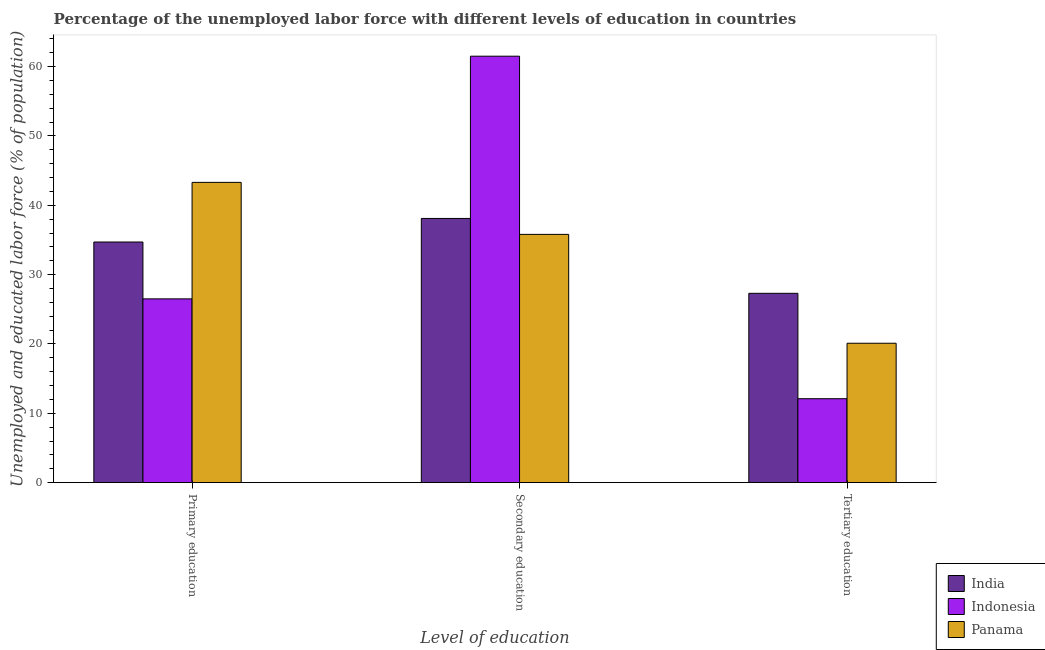How many different coloured bars are there?
Make the answer very short. 3. How many groups of bars are there?
Offer a terse response. 3. What is the label of the 3rd group of bars from the left?
Make the answer very short. Tertiary education. What is the percentage of labor force who received secondary education in Panama?
Provide a succinct answer. 35.8. Across all countries, what is the maximum percentage of labor force who received secondary education?
Provide a short and direct response. 61.5. Across all countries, what is the minimum percentage of labor force who received primary education?
Make the answer very short. 26.5. In which country was the percentage of labor force who received primary education maximum?
Provide a short and direct response. Panama. In which country was the percentage of labor force who received secondary education minimum?
Ensure brevity in your answer.  Panama. What is the total percentage of labor force who received tertiary education in the graph?
Ensure brevity in your answer.  59.5. What is the difference between the percentage of labor force who received tertiary education in Panama and that in India?
Give a very brief answer. -7.2. What is the difference between the percentage of labor force who received primary education in India and the percentage of labor force who received tertiary education in Indonesia?
Provide a succinct answer. 22.6. What is the average percentage of labor force who received tertiary education per country?
Give a very brief answer. 19.83. What is the difference between the percentage of labor force who received primary education and percentage of labor force who received secondary education in Indonesia?
Provide a short and direct response. -35. In how many countries, is the percentage of labor force who received primary education greater than 56 %?
Provide a succinct answer. 0. What is the ratio of the percentage of labor force who received tertiary education in Panama to that in Indonesia?
Ensure brevity in your answer.  1.66. Is the difference between the percentage of labor force who received secondary education in India and Panama greater than the difference between the percentage of labor force who received primary education in India and Panama?
Give a very brief answer. Yes. What is the difference between the highest and the second highest percentage of labor force who received secondary education?
Keep it short and to the point. 23.4. What is the difference between the highest and the lowest percentage of labor force who received secondary education?
Provide a succinct answer. 25.7. In how many countries, is the percentage of labor force who received tertiary education greater than the average percentage of labor force who received tertiary education taken over all countries?
Make the answer very short. 2. Is the sum of the percentage of labor force who received primary education in Panama and Indonesia greater than the maximum percentage of labor force who received tertiary education across all countries?
Provide a succinct answer. Yes. What does the 3rd bar from the left in Tertiary education represents?
Your response must be concise. Panama. What does the 3rd bar from the right in Primary education represents?
Give a very brief answer. India. Is it the case that in every country, the sum of the percentage of labor force who received primary education and percentage of labor force who received secondary education is greater than the percentage of labor force who received tertiary education?
Keep it short and to the point. Yes. How many bars are there?
Your response must be concise. 9. Are all the bars in the graph horizontal?
Offer a terse response. No. How many countries are there in the graph?
Give a very brief answer. 3. What is the difference between two consecutive major ticks on the Y-axis?
Provide a succinct answer. 10. Does the graph contain grids?
Ensure brevity in your answer.  No. How are the legend labels stacked?
Offer a terse response. Vertical. What is the title of the graph?
Make the answer very short. Percentage of the unemployed labor force with different levels of education in countries. Does "Moldova" appear as one of the legend labels in the graph?
Provide a short and direct response. No. What is the label or title of the X-axis?
Provide a succinct answer. Level of education. What is the label or title of the Y-axis?
Your answer should be compact. Unemployed and educated labor force (% of population). What is the Unemployed and educated labor force (% of population) of India in Primary education?
Offer a terse response. 34.7. What is the Unemployed and educated labor force (% of population) in Panama in Primary education?
Your answer should be very brief. 43.3. What is the Unemployed and educated labor force (% of population) of India in Secondary education?
Give a very brief answer. 38.1. What is the Unemployed and educated labor force (% of population) of Indonesia in Secondary education?
Your answer should be compact. 61.5. What is the Unemployed and educated labor force (% of population) of Panama in Secondary education?
Provide a succinct answer. 35.8. What is the Unemployed and educated labor force (% of population) in India in Tertiary education?
Make the answer very short. 27.3. What is the Unemployed and educated labor force (% of population) of Indonesia in Tertiary education?
Provide a short and direct response. 12.1. What is the Unemployed and educated labor force (% of population) in Panama in Tertiary education?
Your response must be concise. 20.1. Across all Level of education, what is the maximum Unemployed and educated labor force (% of population) in India?
Offer a terse response. 38.1. Across all Level of education, what is the maximum Unemployed and educated labor force (% of population) in Indonesia?
Offer a very short reply. 61.5. Across all Level of education, what is the maximum Unemployed and educated labor force (% of population) of Panama?
Give a very brief answer. 43.3. Across all Level of education, what is the minimum Unemployed and educated labor force (% of population) of India?
Provide a short and direct response. 27.3. Across all Level of education, what is the minimum Unemployed and educated labor force (% of population) in Indonesia?
Give a very brief answer. 12.1. Across all Level of education, what is the minimum Unemployed and educated labor force (% of population) in Panama?
Ensure brevity in your answer.  20.1. What is the total Unemployed and educated labor force (% of population) in India in the graph?
Provide a succinct answer. 100.1. What is the total Unemployed and educated labor force (% of population) in Indonesia in the graph?
Offer a terse response. 100.1. What is the total Unemployed and educated labor force (% of population) in Panama in the graph?
Provide a short and direct response. 99.2. What is the difference between the Unemployed and educated labor force (% of population) in India in Primary education and that in Secondary education?
Offer a very short reply. -3.4. What is the difference between the Unemployed and educated labor force (% of population) in Indonesia in Primary education and that in Secondary education?
Your answer should be very brief. -35. What is the difference between the Unemployed and educated labor force (% of population) of India in Primary education and that in Tertiary education?
Offer a terse response. 7.4. What is the difference between the Unemployed and educated labor force (% of population) in Panama in Primary education and that in Tertiary education?
Provide a short and direct response. 23.2. What is the difference between the Unemployed and educated labor force (% of population) of India in Secondary education and that in Tertiary education?
Your response must be concise. 10.8. What is the difference between the Unemployed and educated labor force (% of population) in Indonesia in Secondary education and that in Tertiary education?
Your response must be concise. 49.4. What is the difference between the Unemployed and educated labor force (% of population) of Panama in Secondary education and that in Tertiary education?
Give a very brief answer. 15.7. What is the difference between the Unemployed and educated labor force (% of population) in India in Primary education and the Unemployed and educated labor force (% of population) in Indonesia in Secondary education?
Ensure brevity in your answer.  -26.8. What is the difference between the Unemployed and educated labor force (% of population) in Indonesia in Primary education and the Unemployed and educated labor force (% of population) in Panama in Secondary education?
Your response must be concise. -9.3. What is the difference between the Unemployed and educated labor force (% of population) of India in Primary education and the Unemployed and educated labor force (% of population) of Indonesia in Tertiary education?
Provide a succinct answer. 22.6. What is the difference between the Unemployed and educated labor force (% of population) of India in Secondary education and the Unemployed and educated labor force (% of population) of Indonesia in Tertiary education?
Offer a terse response. 26. What is the difference between the Unemployed and educated labor force (% of population) of Indonesia in Secondary education and the Unemployed and educated labor force (% of population) of Panama in Tertiary education?
Make the answer very short. 41.4. What is the average Unemployed and educated labor force (% of population) in India per Level of education?
Offer a very short reply. 33.37. What is the average Unemployed and educated labor force (% of population) in Indonesia per Level of education?
Give a very brief answer. 33.37. What is the average Unemployed and educated labor force (% of population) of Panama per Level of education?
Give a very brief answer. 33.07. What is the difference between the Unemployed and educated labor force (% of population) in India and Unemployed and educated labor force (% of population) in Panama in Primary education?
Your answer should be very brief. -8.6. What is the difference between the Unemployed and educated labor force (% of population) in Indonesia and Unemployed and educated labor force (% of population) in Panama in Primary education?
Make the answer very short. -16.8. What is the difference between the Unemployed and educated labor force (% of population) in India and Unemployed and educated labor force (% of population) in Indonesia in Secondary education?
Ensure brevity in your answer.  -23.4. What is the difference between the Unemployed and educated labor force (% of population) of India and Unemployed and educated labor force (% of population) of Panama in Secondary education?
Your answer should be very brief. 2.3. What is the difference between the Unemployed and educated labor force (% of population) in Indonesia and Unemployed and educated labor force (% of population) in Panama in Secondary education?
Your response must be concise. 25.7. What is the difference between the Unemployed and educated labor force (% of population) of India and Unemployed and educated labor force (% of population) of Panama in Tertiary education?
Your answer should be compact. 7.2. What is the difference between the Unemployed and educated labor force (% of population) in Indonesia and Unemployed and educated labor force (% of population) in Panama in Tertiary education?
Provide a short and direct response. -8. What is the ratio of the Unemployed and educated labor force (% of population) of India in Primary education to that in Secondary education?
Provide a succinct answer. 0.91. What is the ratio of the Unemployed and educated labor force (% of population) of Indonesia in Primary education to that in Secondary education?
Offer a terse response. 0.43. What is the ratio of the Unemployed and educated labor force (% of population) in Panama in Primary education to that in Secondary education?
Keep it short and to the point. 1.21. What is the ratio of the Unemployed and educated labor force (% of population) in India in Primary education to that in Tertiary education?
Your answer should be compact. 1.27. What is the ratio of the Unemployed and educated labor force (% of population) in Indonesia in Primary education to that in Tertiary education?
Offer a terse response. 2.19. What is the ratio of the Unemployed and educated labor force (% of population) in Panama in Primary education to that in Tertiary education?
Provide a succinct answer. 2.15. What is the ratio of the Unemployed and educated labor force (% of population) of India in Secondary education to that in Tertiary education?
Make the answer very short. 1.4. What is the ratio of the Unemployed and educated labor force (% of population) in Indonesia in Secondary education to that in Tertiary education?
Keep it short and to the point. 5.08. What is the ratio of the Unemployed and educated labor force (% of population) in Panama in Secondary education to that in Tertiary education?
Provide a succinct answer. 1.78. What is the difference between the highest and the second highest Unemployed and educated labor force (% of population) of India?
Your response must be concise. 3.4. What is the difference between the highest and the second highest Unemployed and educated labor force (% of population) in Panama?
Give a very brief answer. 7.5. What is the difference between the highest and the lowest Unemployed and educated labor force (% of population) of Indonesia?
Your response must be concise. 49.4. What is the difference between the highest and the lowest Unemployed and educated labor force (% of population) of Panama?
Keep it short and to the point. 23.2. 